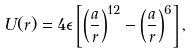<formula> <loc_0><loc_0><loc_500><loc_500>U ( r ) = 4 \epsilon \left [ \left ( \frac { a } { r } \right ) ^ { 1 2 } - \left ( \frac { a } { r } \right ) ^ { 6 } \right ] ,</formula> 